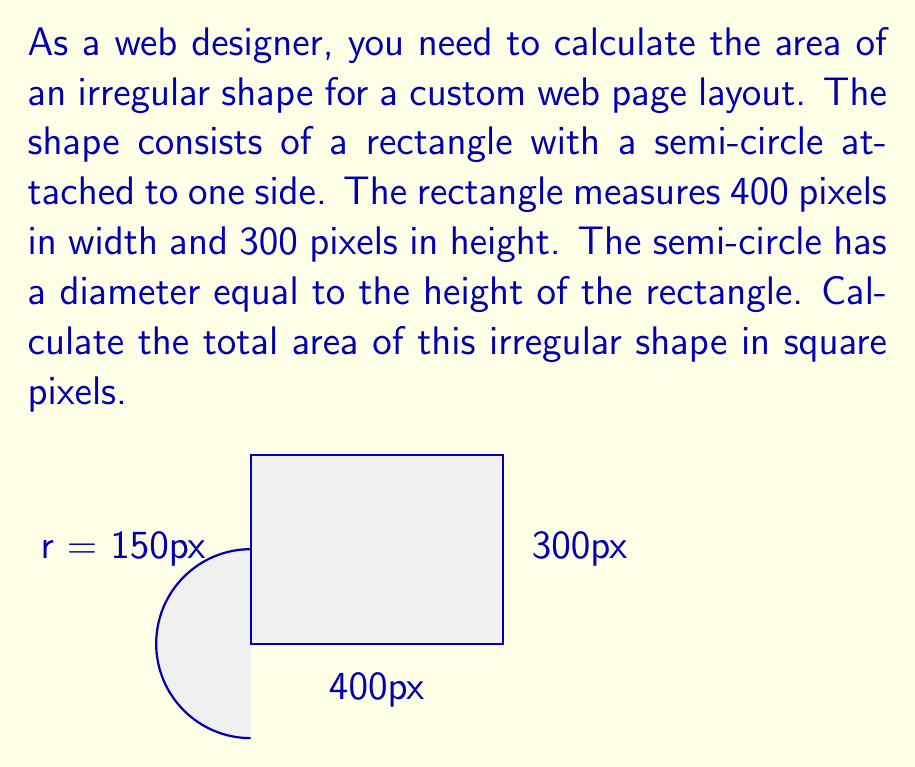Help me with this question. To solve this problem, we need to break it down into two parts: the area of the rectangle and the area of the semi-circle. Then, we'll add these areas together.

1. Calculate the area of the rectangle:
   $A_{rectangle} = width \times height$
   $A_{rectangle} = 400 \times 300 = 120,000$ square pixels

2. Calculate the area of the semi-circle:
   The diameter of the semi-circle is equal to the height of the rectangle, which is 300 pixels.
   Therefore, the radius is half of this, 150 pixels.

   Area of a full circle: $A_{circle} = \pi r^2$
   Area of a semi-circle: $A_{semi-circle} = \frac{1}{2} \pi r^2$

   $A_{semi-circle} = \frac{1}{2} \times \pi \times 150^2$
   $A_{semi-circle} = \frac{1}{2} \times \pi \times 22,500$
   $A_{semi-circle} \approx 35,343.75$ square pixels

3. Calculate the total area by adding the two parts:
   $A_{total} = A_{rectangle} + A_{semi-circle}$
   $A_{total} = 120,000 + 35,343.75$
   $A_{total} = 155,343.75$ square pixels

Therefore, the total area of the irregular shape is approximately 155,344 square pixels (rounded to the nearest whole pixel).
Answer: 155,344 square pixels 